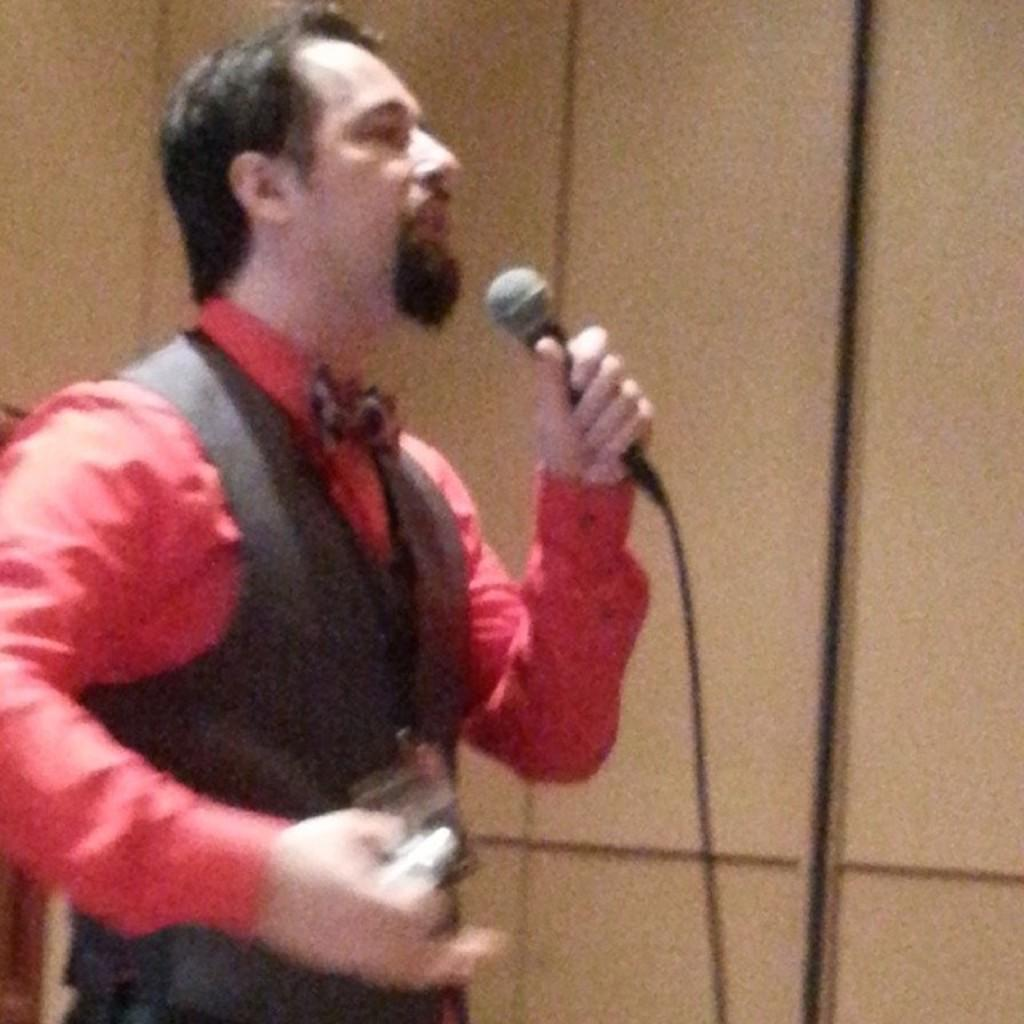What is the main subject of the image? There is a person in the image. What is the person holding in the image? The person is holding a microphone (mike) in the image. What color is the shirt the person is wearing? The person is wearing a red shirt in the image. What type of clothing is the person wearing on top of their shirt? The person is wearing a black suit in the image. What type of insurance does the person's brother have in the image? There is no mention of a brother or insurance in the image, so it cannot be determined. 